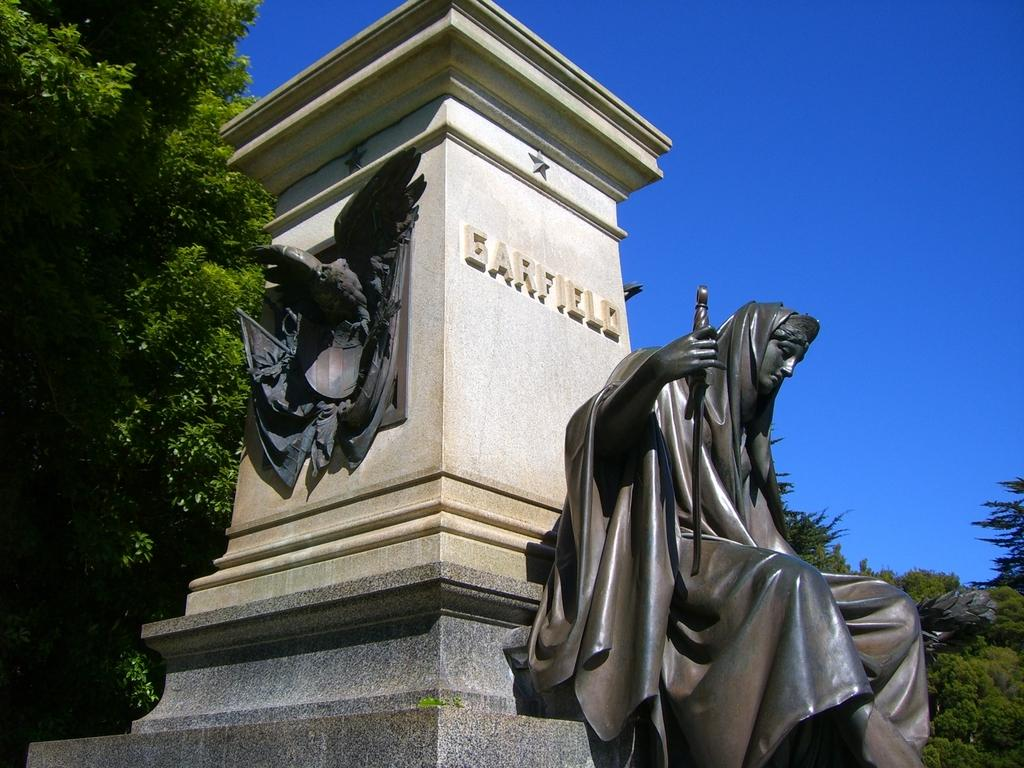What type of objects can be seen in the image? There are statues in the image. What other elements can be found in the image? There are trees in the image. Is there any text or writing visible in the image? Yes, there is a name on a wall in the image. What can be seen in the background of the image? The sky is visible in the background of the image. What type of drink is being served at the crime scene in the image? There is no crime scene or drink present in the image. 